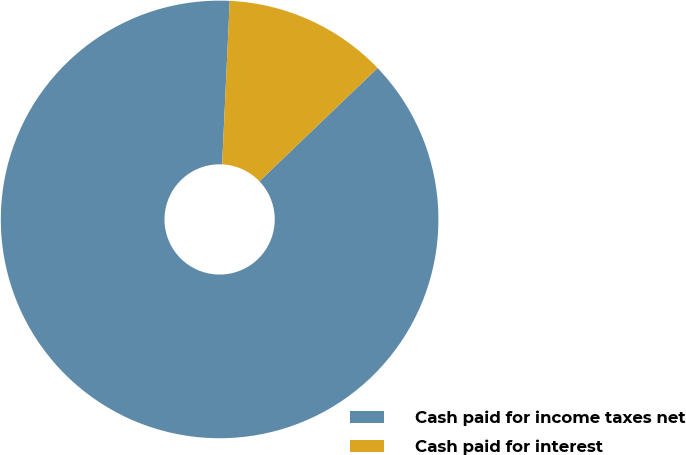<chart> <loc_0><loc_0><loc_500><loc_500><pie_chart><fcel>Cash paid for income taxes net<fcel>Cash paid for interest<nl><fcel>87.9%<fcel>12.1%<nl></chart> 